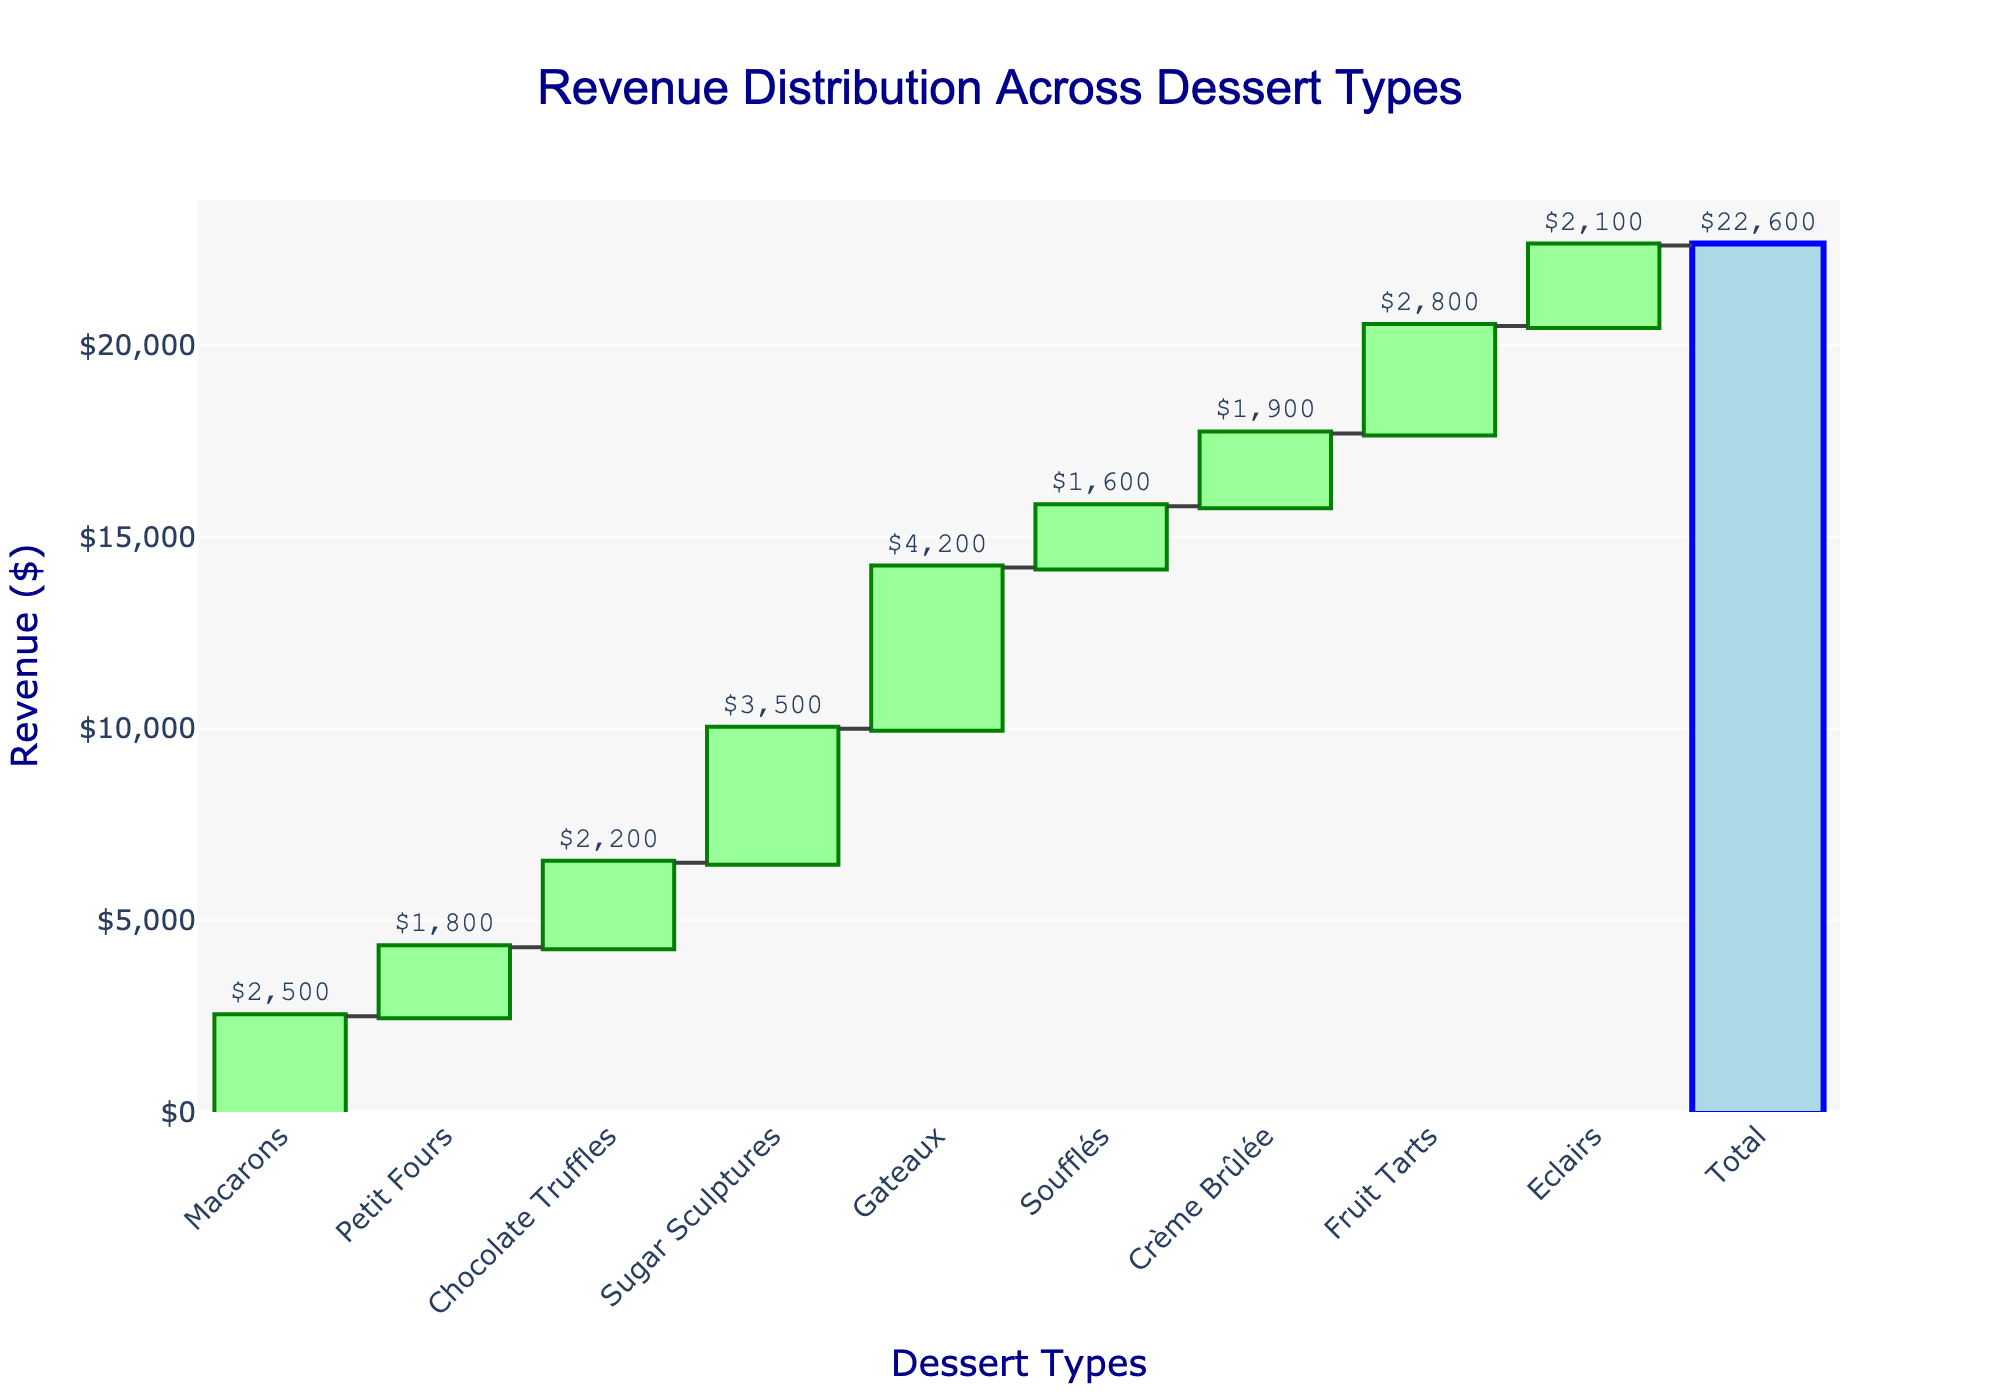what is the title of the chart? The title is located at the top of the chart. It is usually larger in size and different in color compared to other text elements. It helps in understanding the primary focus of the chart. In this case, the title reads clearly at the top.
Answer: Revenue Distribution Across Dessert Types How many dessert types are displayed, excluding the total? Count the individual categories listed along the x-axis, excluding the final "Total" category. These are all the dessert types.
Answer: 9 Which dessert type contributes the highest revenue? Identify the bar with the greatest height among the dessert categories on the x-axis. This bar visually represents the highest revenue contribution.
Answer: Gateaux What is the revenue contribution of Chocolate Truffles? Locate the bar labeled "Chocolate Truffles" along the x-axis. The revenue value is displayed alongside or above the bar.
Answer: $2,200 How much more revenue do Sugar Sculptures generate than Petit Fours? Find the revenue values for both Sugar Sculptures and Petit Fours. Subtract the revenue of Petit Fours from that of Sugar Sculptures to get the difference.
Answer: $1,700 What is the overall revenue generated from all the dessert types combined? The "Total" bar displays this value at the end of the x-axis. It represents the sum of all individual dessert revenues.
Answer: $22,600 Which dessert type has the smallest revenue contribution, and what is its value? Identify the bar with the smallest height among the dessert categories. The corresponding label and value will tell the type and its revenue.
Answer: Soufflés, $1,600 How does the revenue from Eclairs compare to that from Fruit Tarts? Locate the bars corresponding to Eclairs and Fruit Tarts. Compare their heights or values to determine which is higher.
Answer: Fruit Tarts generate more revenue What is the average revenue per dessert type (excluding total)? Sum the revenues for all dessert types and divide by the number of types. This will give the average revenue per type.
Answer: $23,000 / 9 ≈ $2,556 What supplementary imagery is used in the chart? There is an image faintly overlaid in the background of the chart, often to add thematic relevance or aesthetic appeal. It appears at the center and is connected with sugar sculptures.
Answer: A sugar sculpture silhouette 